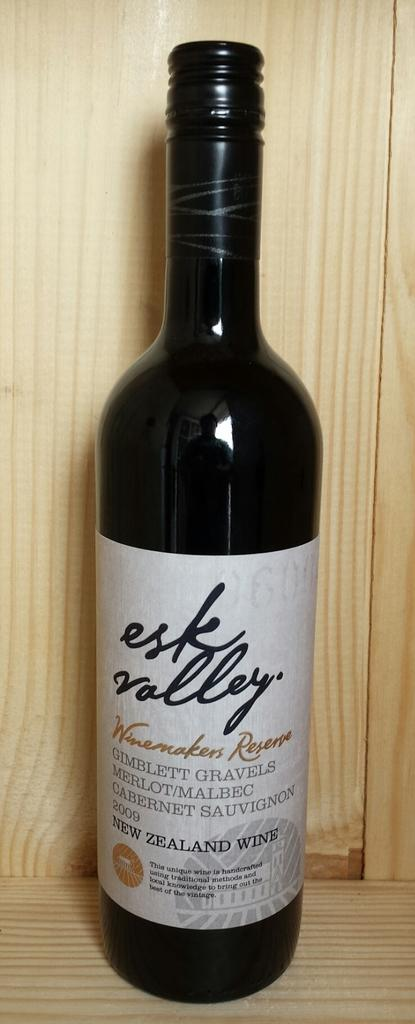<image>
Describe the image concisely. A bottle of New Zealand wine that reads esk valley. 